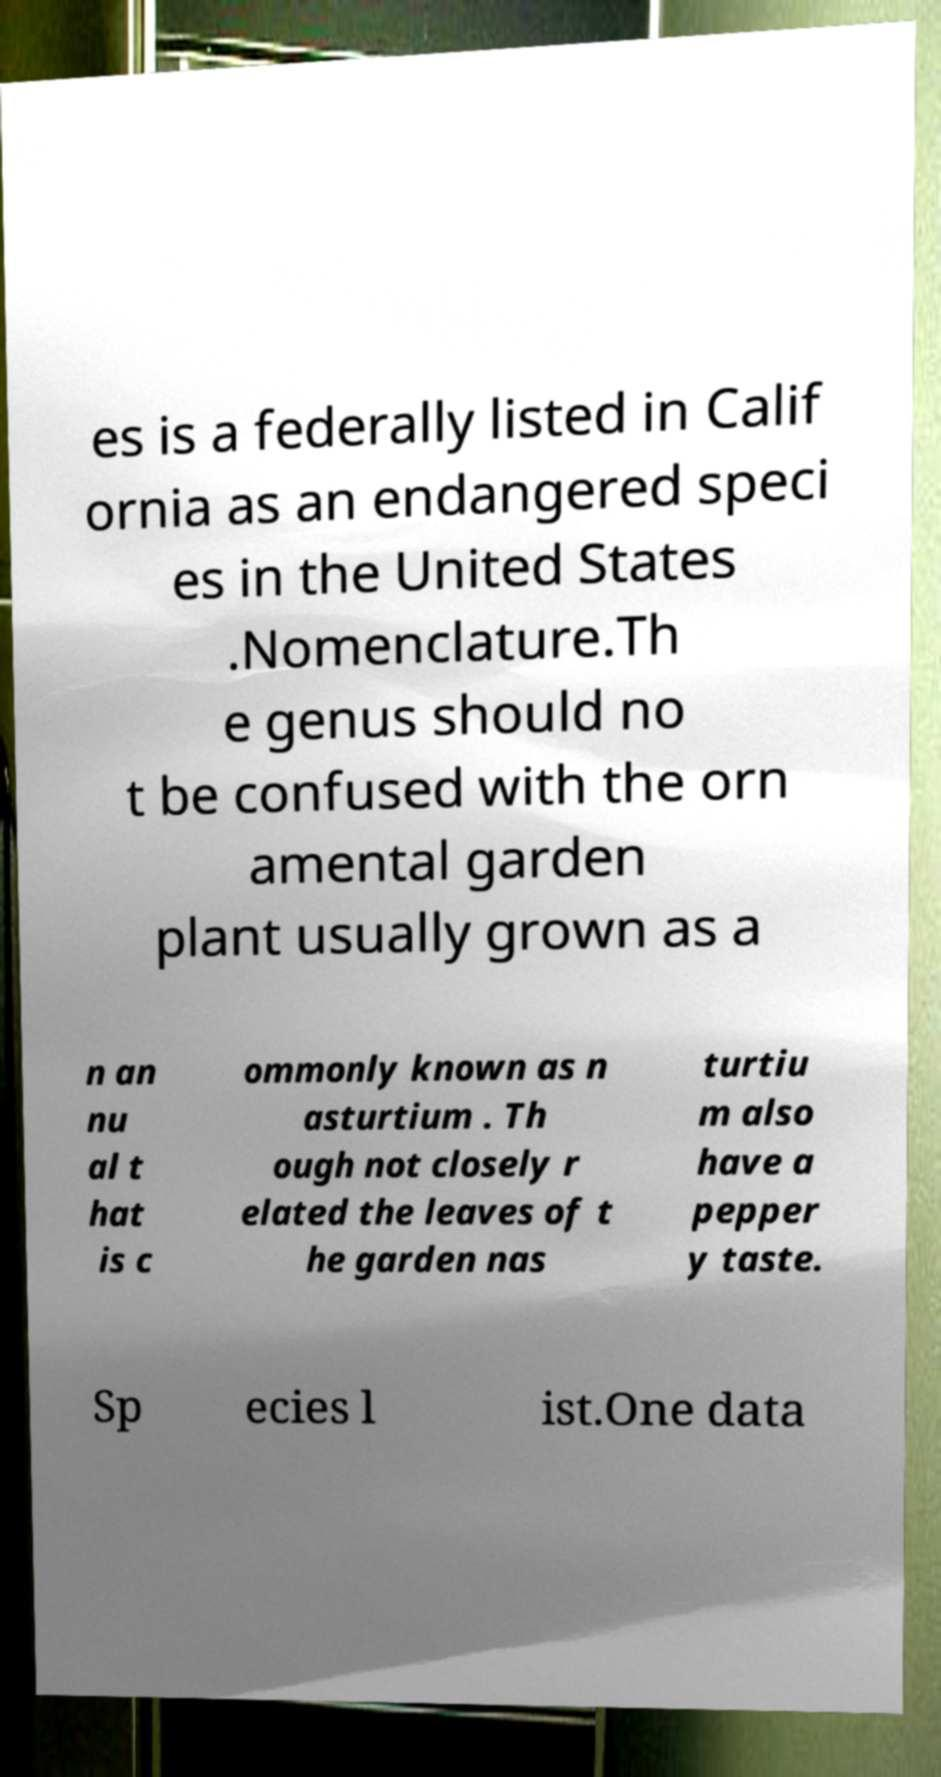What messages or text are displayed in this image? I need them in a readable, typed format. es is a federally listed in Calif ornia as an endangered speci es in the United States .Nomenclature.Th e genus should no t be confused with the orn amental garden plant usually grown as a n an nu al t hat is c ommonly known as n asturtium . Th ough not closely r elated the leaves of t he garden nas turtiu m also have a pepper y taste. Sp ecies l ist.One data 